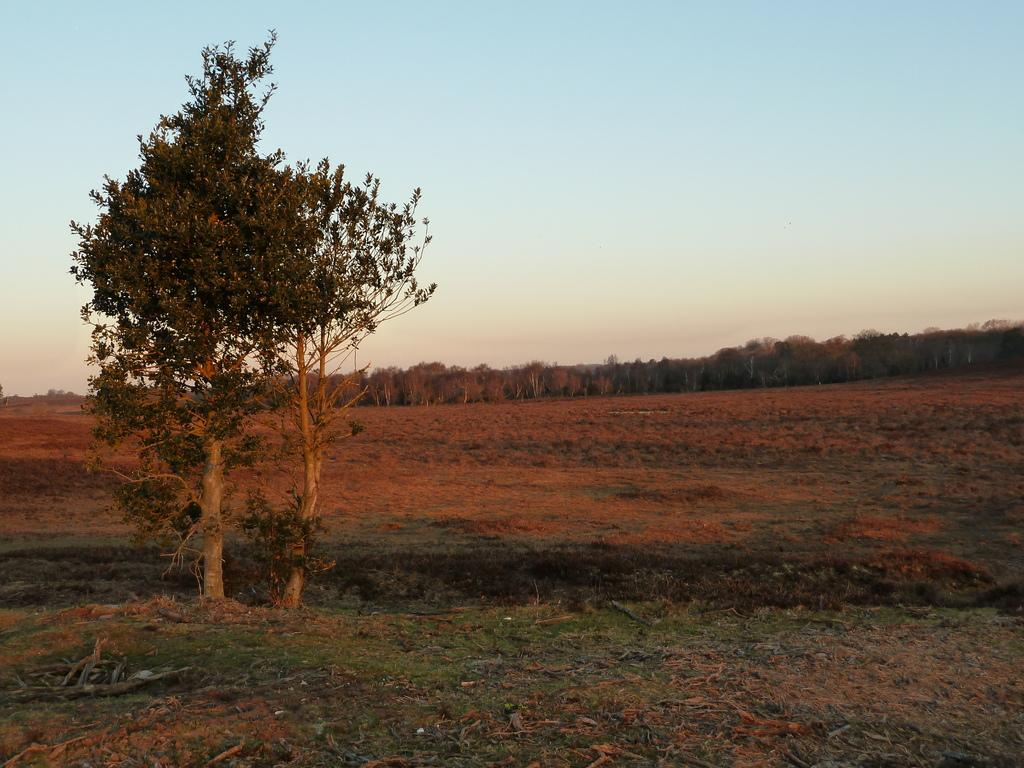What type of vegetation is at the bottom of the image? There is grass and dry leaves and twigs at the bottom of the image. What can be seen on the left side of the image? There is a tree on the left side of the image. What is visible in the background of the image? There are trees in the background of the image. What is visible at the top of the image? The sky is visible at the top of the image. What type of crowd can be seen playing chess in the image? There is no crowd or chess game present in the image. What is the surprise element in the image? There is no surprise element mentioned in the provided facts, as the image only contains grass, dry leaves and twigs, a tree, trees in the background, and the sky. 